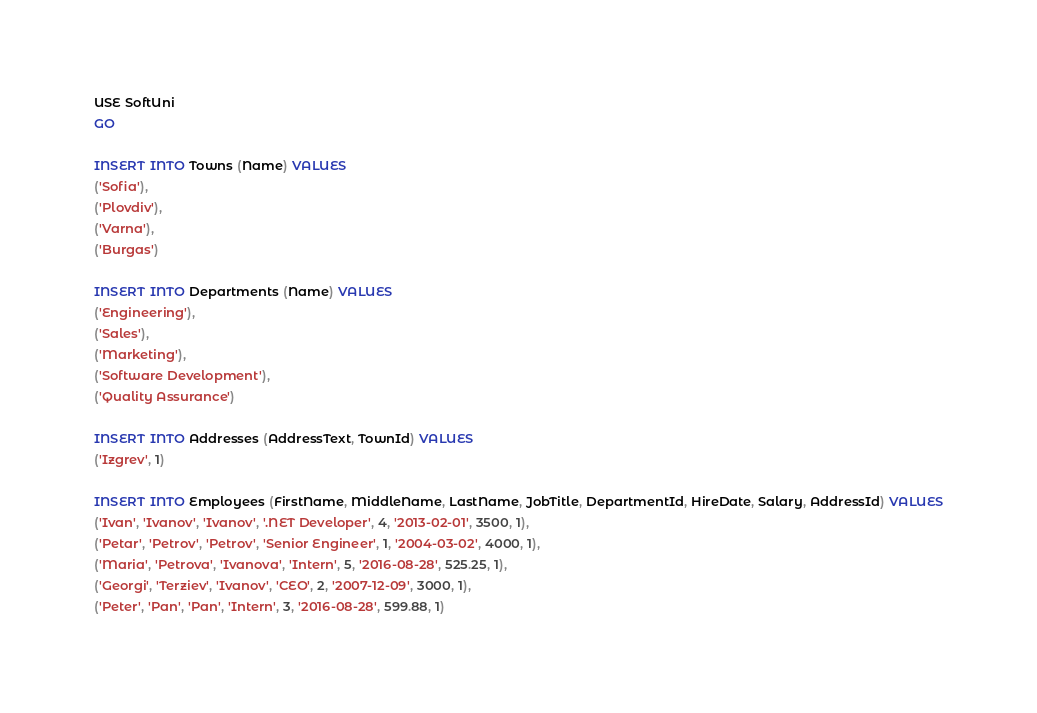<code> <loc_0><loc_0><loc_500><loc_500><_SQL_>USE SoftUni
GO

INSERT INTO Towns (Name) VALUES
('Sofia'),
('Plovdiv'),
('Varna'),
('Burgas')

INSERT INTO Departments (Name) VALUES
('Engineering'),
('Sales'),
('Marketing'),
('Software Development'),
('Quality Assurance')

INSERT INTO Addresses (AddressText, TownId) VALUES
('Izgrev', 1)

INSERT INTO Employees (FirstName, MiddleName, LastName, JobTitle, DepartmentId, HireDate, Salary, AddressId) VALUES
('Ivan', 'Ivanov', 'Ivanov', '.NET Developer', 4, '2013-02-01', 3500, 1),
('Petar', 'Petrov', 'Petrov', 'Senior Engineer', 1, '2004-03-02', 4000, 1),
('Maria', 'Petrova', 'Ivanova', 'Intern', 5, '2016-08-28', 525.25, 1),
('Georgi', 'Terziev', 'Ivanov', 'CEO', 2, '2007-12-09', 3000, 1),
('Peter', 'Pan', 'Pan', 'Intern', 3, '2016-08-28', 599.88, 1)</code> 